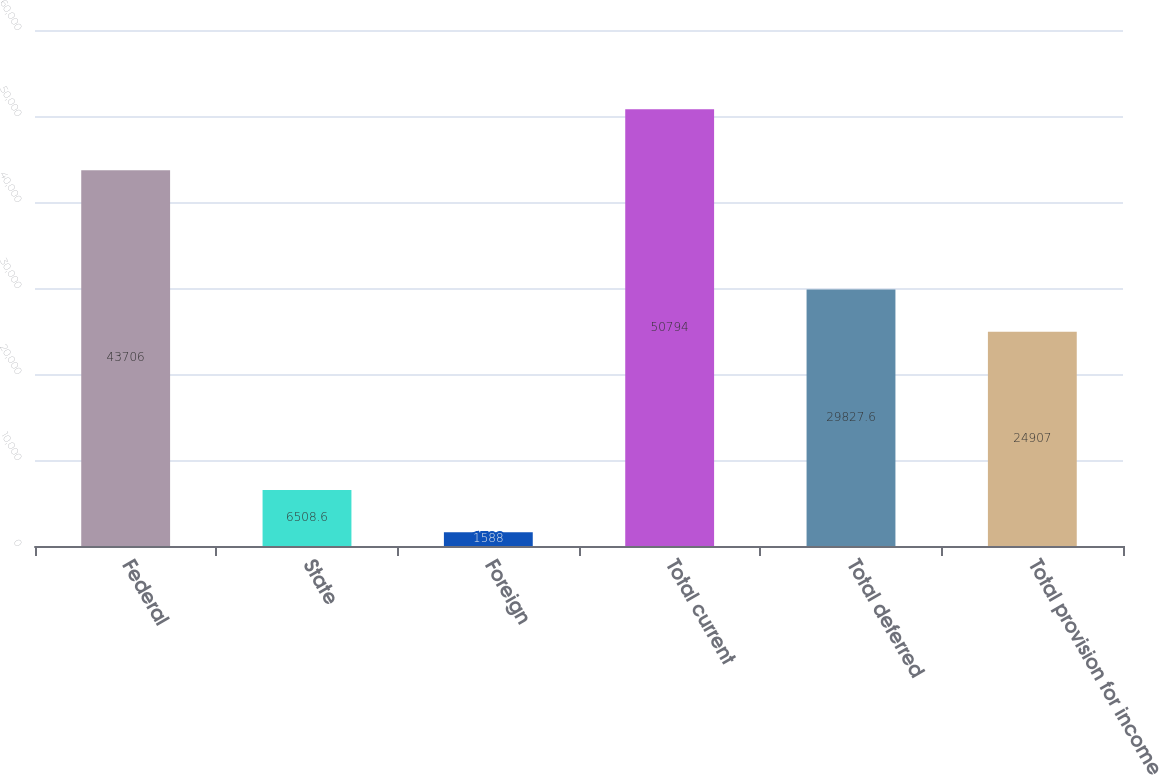<chart> <loc_0><loc_0><loc_500><loc_500><bar_chart><fcel>Federal<fcel>State<fcel>Foreign<fcel>Total current<fcel>Total deferred<fcel>Total provision for income<nl><fcel>43706<fcel>6508.6<fcel>1588<fcel>50794<fcel>29827.6<fcel>24907<nl></chart> 